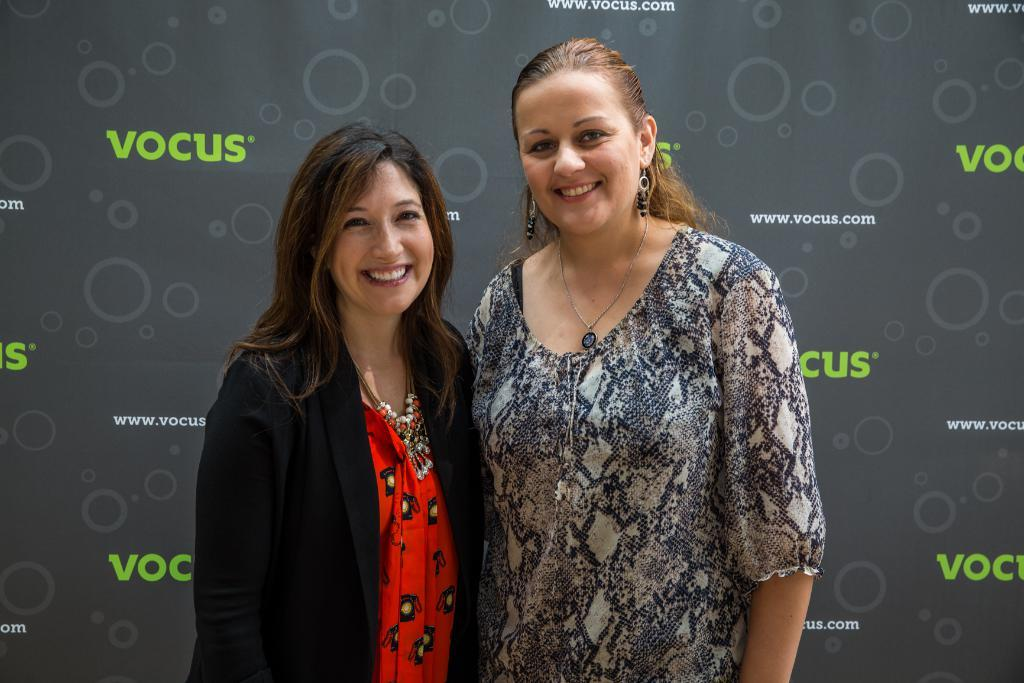How many people are in the image? There are two persons in the image. What are the two persons doing in the image? The two persons are standing. What expressions do the two persons have in the image? The two persons are smiling. What can be seen in the background of the image? There is a board in the background of the image. What type of maid can be seen in the image? There is no maid present in the image. What is the income of the persons in the image? The income of the persons in the image cannot be determined from the image. 